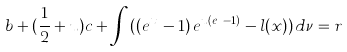<formula> <loc_0><loc_0><loc_500><loc_500>b + ( \frac { 1 } { 2 } + u ) c + \int _ { \mathbb { R } } ( ( e ^ { x } \, - 1 ) \, e ^ { u ( e ^ { x } - 1 ) } - l ( x ) ) \, d \nu = r</formula> 